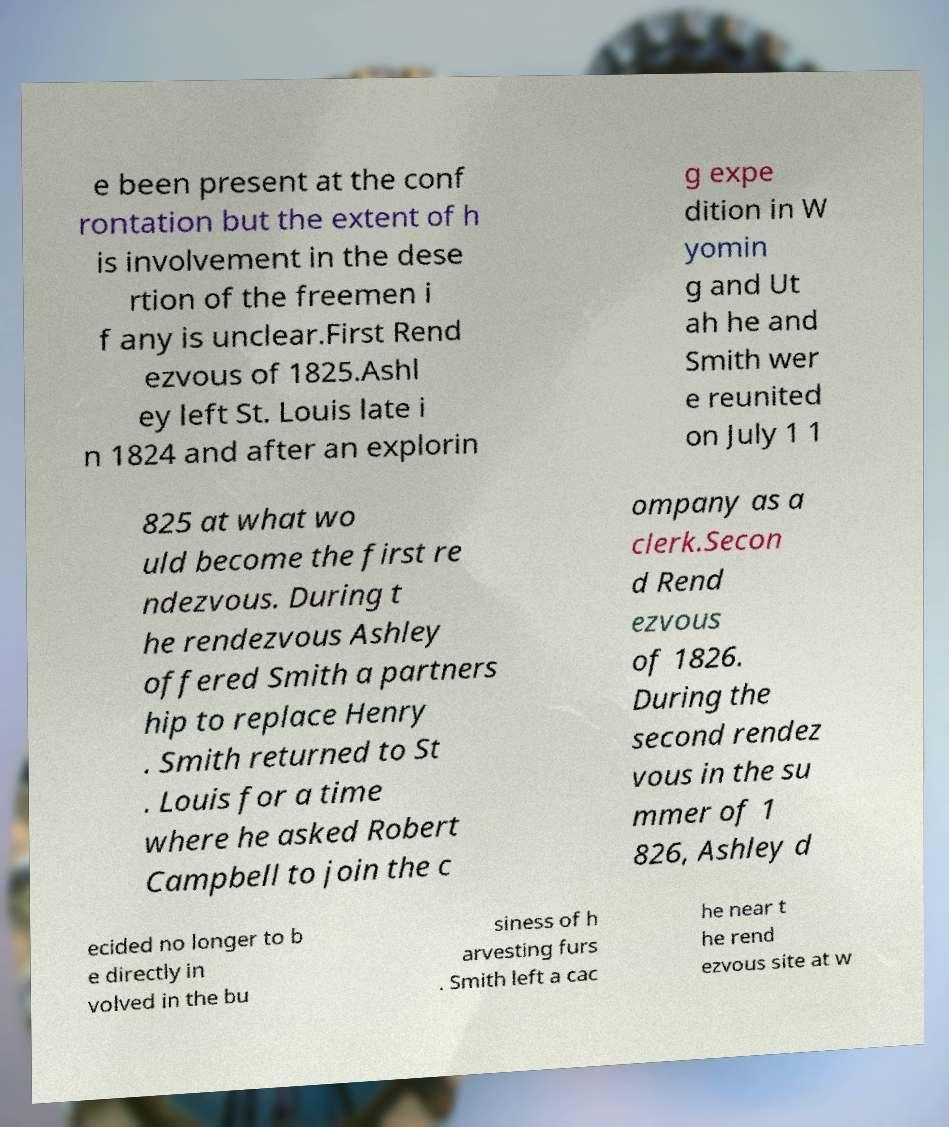Could you extract and type out the text from this image? e been present at the conf rontation but the extent of h is involvement in the dese rtion of the freemen i f any is unclear.First Rend ezvous of 1825.Ashl ey left St. Louis late i n 1824 and after an explorin g expe dition in W yomin g and Ut ah he and Smith wer e reunited on July 1 1 825 at what wo uld become the first re ndezvous. During t he rendezvous Ashley offered Smith a partners hip to replace Henry . Smith returned to St . Louis for a time where he asked Robert Campbell to join the c ompany as a clerk.Secon d Rend ezvous of 1826. During the second rendez vous in the su mmer of 1 826, Ashley d ecided no longer to b e directly in volved in the bu siness of h arvesting furs . Smith left a cac he near t he rend ezvous site at w 